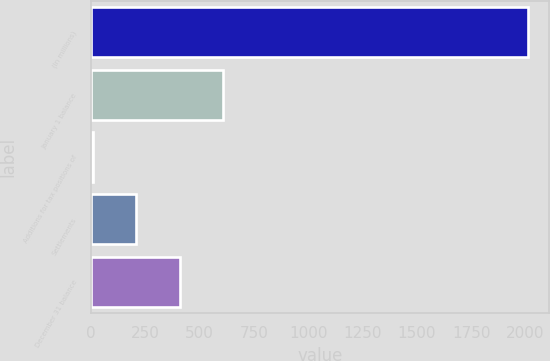<chart> <loc_0><loc_0><loc_500><loc_500><bar_chart><fcel>(In millions)<fcel>January 1 balance<fcel>Additions for tax positions of<fcel>Settlements<fcel>December 31 balance<nl><fcel>2010<fcel>607.9<fcel>7<fcel>207.3<fcel>407.6<nl></chart> 